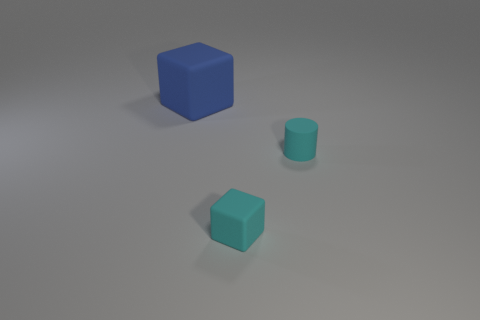Add 3 tiny blocks. How many objects exist? 6 Subtract all cylinders. How many objects are left? 2 Subtract 0 cyan balls. How many objects are left? 3 Subtract all large red matte cylinders. Subtract all tiny cubes. How many objects are left? 2 Add 3 small matte cylinders. How many small matte cylinders are left? 4 Add 2 small shiny objects. How many small shiny objects exist? 2 